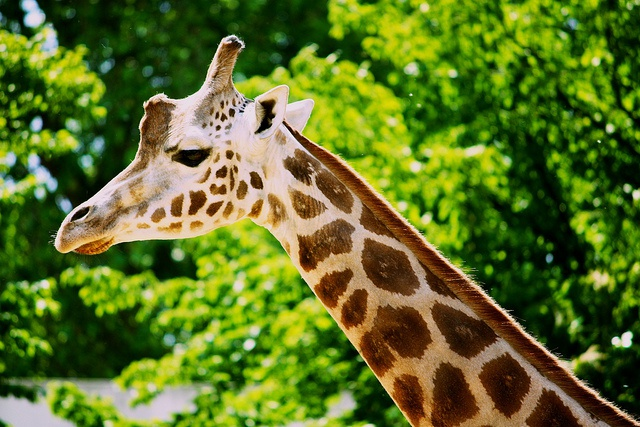Describe the objects in this image and their specific colors. I can see a giraffe in darkgreen, maroon, black, lightgray, and tan tones in this image. 